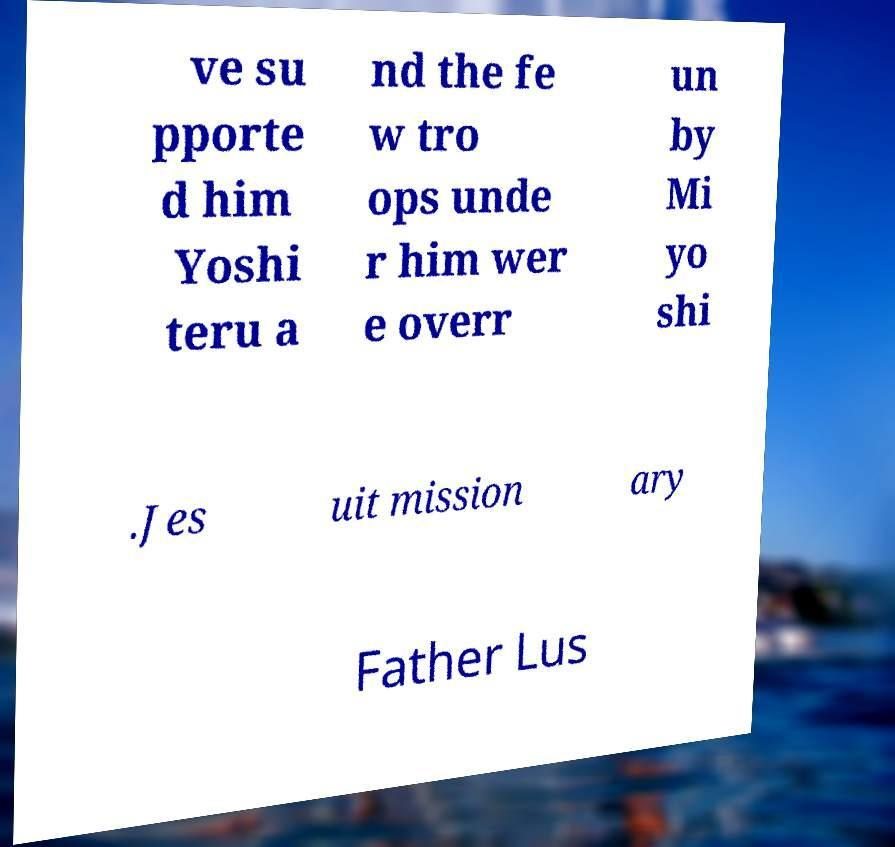Can you read and provide the text displayed in the image?This photo seems to have some interesting text. Can you extract and type it out for me? ve su pporte d him Yoshi teru a nd the fe w tro ops unde r him wer e overr un by Mi yo shi .Jes uit mission ary Father Lus 